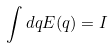<formula> <loc_0><loc_0><loc_500><loc_500>\int d q E ( q ) = I</formula> 